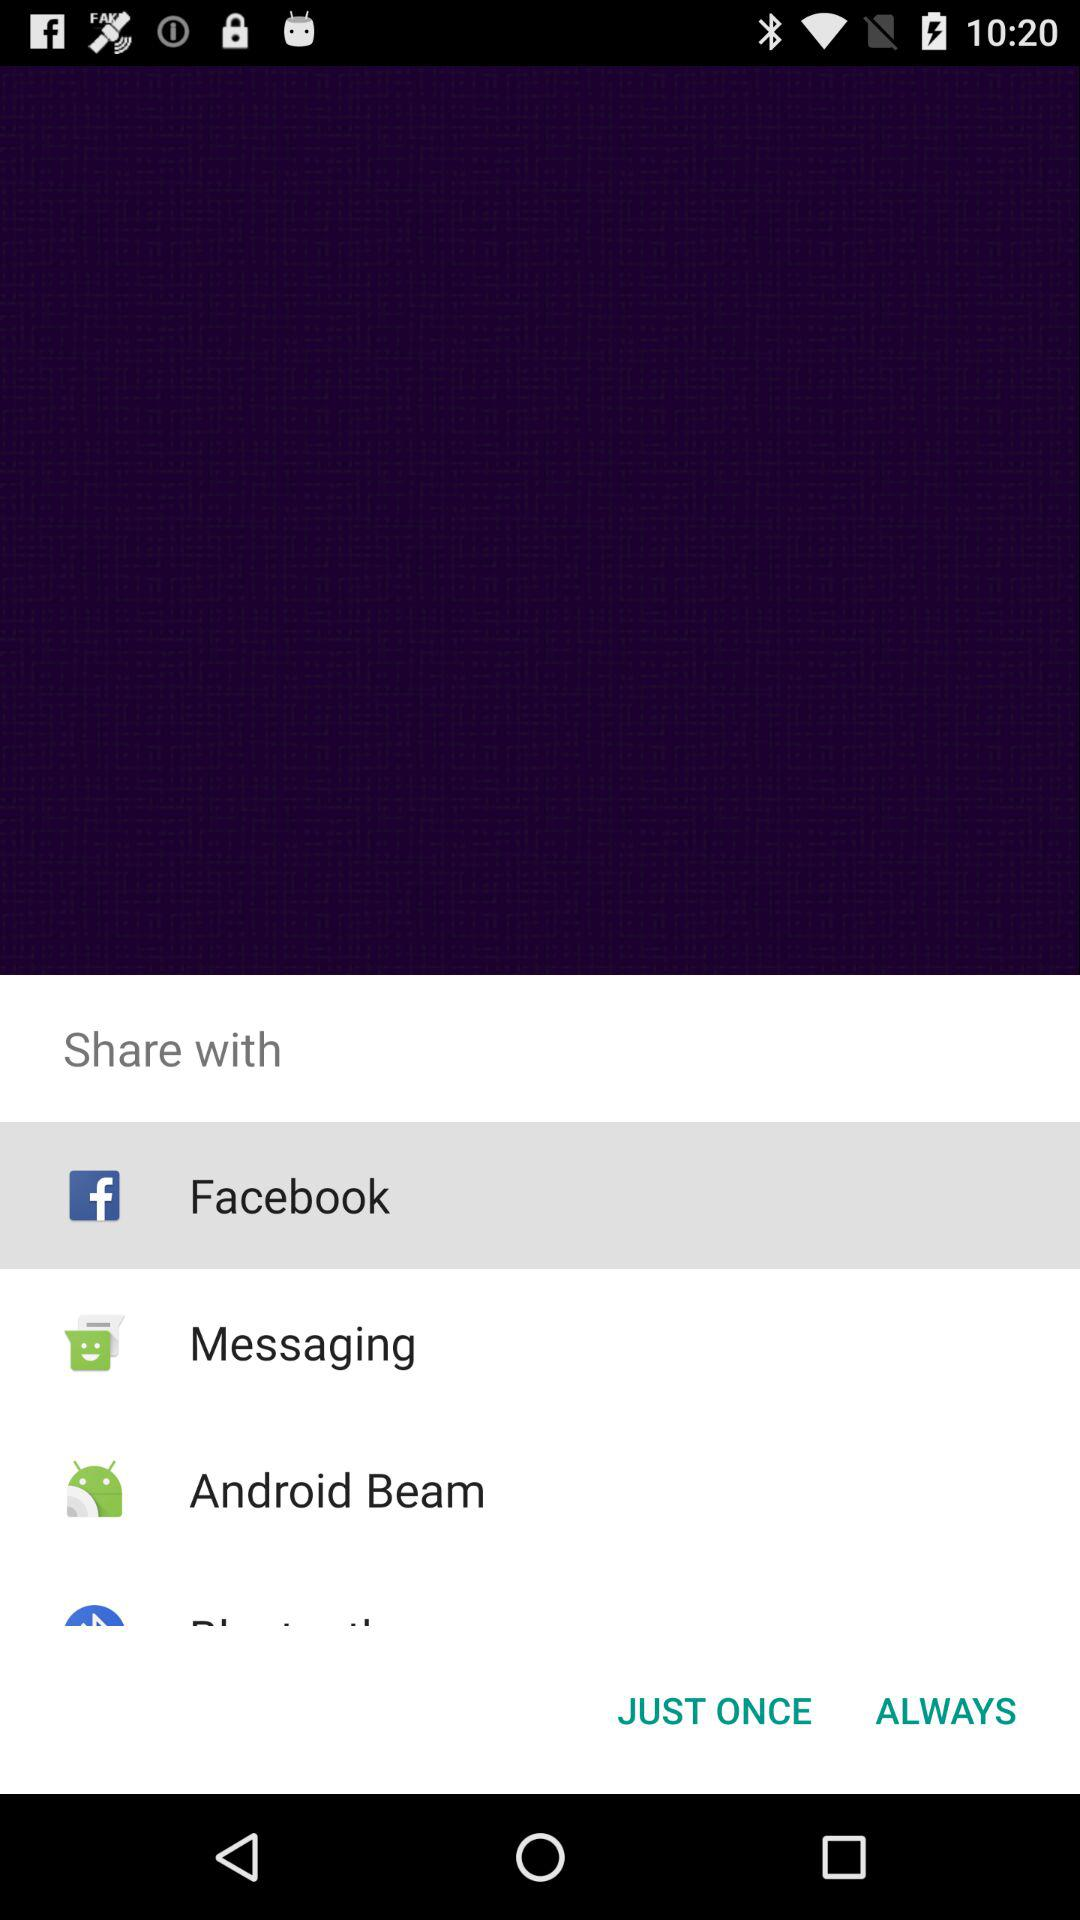Which are the different options to share? The different options to share are "Facebook", "Messaging" and "Android Beam". 